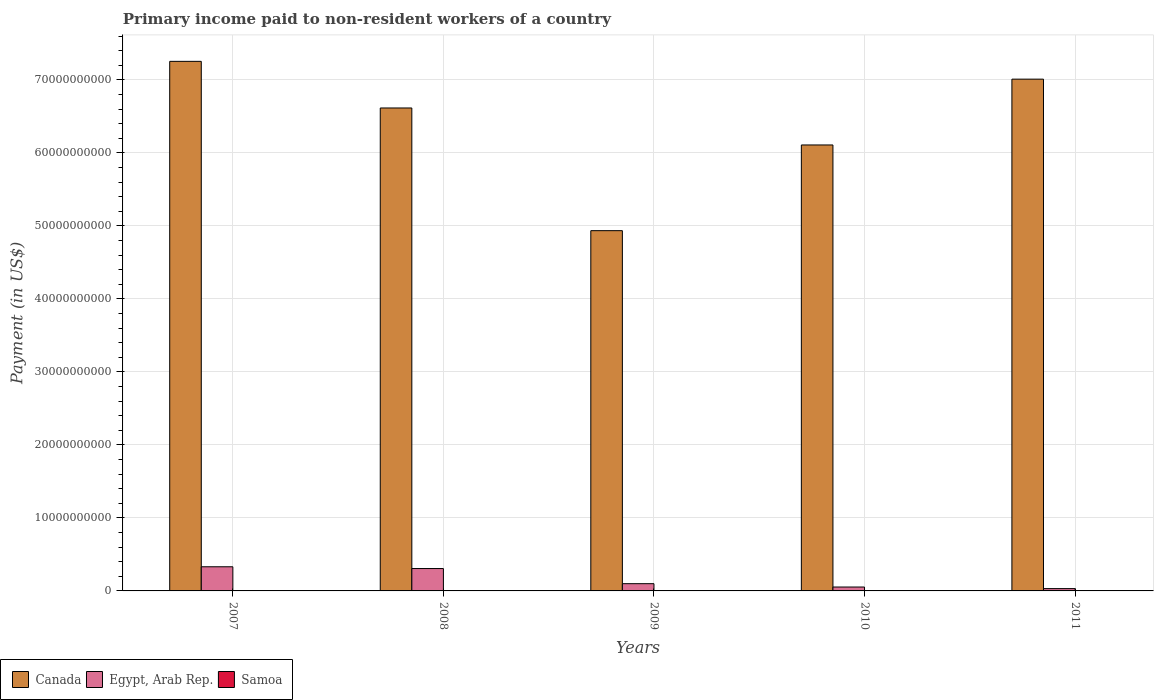How many different coloured bars are there?
Make the answer very short. 3. Are the number of bars per tick equal to the number of legend labels?
Ensure brevity in your answer.  Yes. What is the amount paid to workers in Egypt, Arab Rep. in 2011?
Offer a very short reply. 3.18e+08. Across all years, what is the maximum amount paid to workers in Canada?
Provide a succinct answer. 7.26e+1. Across all years, what is the minimum amount paid to workers in Egypt, Arab Rep.?
Keep it short and to the point. 3.18e+08. What is the total amount paid to workers in Egypt, Arab Rep. in the graph?
Your answer should be compact. 8.22e+09. What is the difference between the amount paid to workers in Egypt, Arab Rep. in 2007 and that in 2008?
Provide a short and direct response. 2.44e+08. What is the difference between the amount paid to workers in Samoa in 2008 and the amount paid to workers in Egypt, Arab Rep. in 2009?
Keep it short and to the point. -9.79e+08. What is the average amount paid to workers in Samoa per year?
Keep it short and to the point. 8.09e+06. In the year 2011, what is the difference between the amount paid to workers in Samoa and amount paid to workers in Canada?
Your response must be concise. -7.01e+1. What is the ratio of the amount paid to workers in Samoa in 2009 to that in 2011?
Make the answer very short. 1.34. Is the amount paid to workers in Egypt, Arab Rep. in 2008 less than that in 2010?
Give a very brief answer. No. Is the difference between the amount paid to workers in Samoa in 2009 and 2010 greater than the difference between the amount paid to workers in Canada in 2009 and 2010?
Your response must be concise. Yes. What is the difference between the highest and the second highest amount paid to workers in Samoa?
Make the answer very short. 5.60e+06. What is the difference between the highest and the lowest amount paid to workers in Egypt, Arab Rep.?
Your response must be concise. 2.99e+09. What does the 1st bar from the left in 2007 represents?
Provide a succinct answer. Canada. How many bars are there?
Provide a short and direct response. 15. Are all the bars in the graph horizontal?
Your response must be concise. No. Are the values on the major ticks of Y-axis written in scientific E-notation?
Your response must be concise. No. Does the graph contain any zero values?
Ensure brevity in your answer.  No. What is the title of the graph?
Your answer should be compact. Primary income paid to non-resident workers of a country. What is the label or title of the X-axis?
Offer a very short reply. Years. What is the label or title of the Y-axis?
Give a very brief answer. Payment (in US$). What is the Payment (in US$) in Canada in 2007?
Your response must be concise. 7.26e+1. What is the Payment (in US$) of Egypt, Arab Rep. in 2007?
Offer a very short reply. 3.31e+09. What is the Payment (in US$) in Samoa in 2007?
Give a very brief answer. 6.74e+06. What is the Payment (in US$) of Canada in 2008?
Offer a terse response. 6.62e+1. What is the Payment (in US$) of Egypt, Arab Rep. in 2008?
Your answer should be very brief. 3.07e+09. What is the Payment (in US$) of Samoa in 2008?
Give a very brief answer. 1.33e+07. What is the Payment (in US$) of Canada in 2009?
Provide a short and direct response. 4.94e+1. What is the Payment (in US$) of Egypt, Arab Rep. in 2009?
Give a very brief answer. 9.92e+08. What is the Payment (in US$) in Samoa in 2009?
Give a very brief answer. 7.75e+06. What is the Payment (in US$) of Canada in 2010?
Offer a terse response. 6.11e+1. What is the Payment (in US$) of Egypt, Arab Rep. in 2010?
Your response must be concise. 5.34e+08. What is the Payment (in US$) of Samoa in 2010?
Ensure brevity in your answer.  6.81e+06. What is the Payment (in US$) of Canada in 2011?
Your response must be concise. 7.01e+1. What is the Payment (in US$) in Egypt, Arab Rep. in 2011?
Ensure brevity in your answer.  3.18e+08. What is the Payment (in US$) of Samoa in 2011?
Offer a terse response. 5.80e+06. Across all years, what is the maximum Payment (in US$) of Canada?
Offer a very short reply. 7.26e+1. Across all years, what is the maximum Payment (in US$) in Egypt, Arab Rep.?
Offer a terse response. 3.31e+09. Across all years, what is the maximum Payment (in US$) of Samoa?
Keep it short and to the point. 1.33e+07. Across all years, what is the minimum Payment (in US$) of Canada?
Provide a short and direct response. 4.94e+1. Across all years, what is the minimum Payment (in US$) of Egypt, Arab Rep.?
Provide a succinct answer. 3.18e+08. Across all years, what is the minimum Payment (in US$) in Samoa?
Make the answer very short. 5.80e+06. What is the total Payment (in US$) in Canada in the graph?
Make the answer very short. 3.19e+11. What is the total Payment (in US$) of Egypt, Arab Rep. in the graph?
Offer a terse response. 8.22e+09. What is the total Payment (in US$) in Samoa in the graph?
Offer a very short reply. 4.04e+07. What is the difference between the Payment (in US$) in Canada in 2007 and that in 2008?
Offer a terse response. 6.39e+09. What is the difference between the Payment (in US$) of Egypt, Arab Rep. in 2007 and that in 2008?
Your answer should be very brief. 2.44e+08. What is the difference between the Payment (in US$) of Samoa in 2007 and that in 2008?
Your answer should be very brief. -6.61e+06. What is the difference between the Payment (in US$) of Canada in 2007 and that in 2009?
Provide a succinct answer. 2.32e+1. What is the difference between the Payment (in US$) in Egypt, Arab Rep. in 2007 and that in 2009?
Provide a succinct answer. 2.32e+09. What is the difference between the Payment (in US$) in Samoa in 2007 and that in 2009?
Give a very brief answer. -1.01e+06. What is the difference between the Payment (in US$) of Canada in 2007 and that in 2010?
Your response must be concise. 1.15e+1. What is the difference between the Payment (in US$) in Egypt, Arab Rep. in 2007 and that in 2010?
Make the answer very short. 2.78e+09. What is the difference between the Payment (in US$) in Samoa in 2007 and that in 2010?
Provide a short and direct response. -7.51e+04. What is the difference between the Payment (in US$) in Canada in 2007 and that in 2011?
Give a very brief answer. 2.44e+09. What is the difference between the Payment (in US$) in Egypt, Arab Rep. in 2007 and that in 2011?
Offer a very short reply. 2.99e+09. What is the difference between the Payment (in US$) in Samoa in 2007 and that in 2011?
Your answer should be compact. 9.42e+05. What is the difference between the Payment (in US$) in Canada in 2008 and that in 2009?
Provide a succinct answer. 1.68e+1. What is the difference between the Payment (in US$) in Egypt, Arab Rep. in 2008 and that in 2009?
Your response must be concise. 2.07e+09. What is the difference between the Payment (in US$) of Samoa in 2008 and that in 2009?
Provide a succinct answer. 5.60e+06. What is the difference between the Payment (in US$) in Canada in 2008 and that in 2010?
Offer a very short reply. 5.07e+09. What is the difference between the Payment (in US$) in Egypt, Arab Rep. in 2008 and that in 2010?
Ensure brevity in your answer.  2.53e+09. What is the difference between the Payment (in US$) in Samoa in 2008 and that in 2010?
Make the answer very short. 6.53e+06. What is the difference between the Payment (in US$) in Canada in 2008 and that in 2011?
Give a very brief answer. -3.95e+09. What is the difference between the Payment (in US$) of Egypt, Arab Rep. in 2008 and that in 2011?
Provide a succinct answer. 2.75e+09. What is the difference between the Payment (in US$) in Samoa in 2008 and that in 2011?
Offer a terse response. 7.55e+06. What is the difference between the Payment (in US$) of Canada in 2009 and that in 2010?
Provide a short and direct response. -1.17e+1. What is the difference between the Payment (in US$) of Egypt, Arab Rep. in 2009 and that in 2010?
Your answer should be compact. 4.58e+08. What is the difference between the Payment (in US$) in Samoa in 2009 and that in 2010?
Provide a succinct answer. 9.38e+05. What is the difference between the Payment (in US$) of Canada in 2009 and that in 2011?
Your response must be concise. -2.08e+1. What is the difference between the Payment (in US$) of Egypt, Arab Rep. in 2009 and that in 2011?
Make the answer very short. 6.74e+08. What is the difference between the Payment (in US$) of Samoa in 2009 and that in 2011?
Your answer should be compact. 1.95e+06. What is the difference between the Payment (in US$) in Canada in 2010 and that in 2011?
Provide a short and direct response. -9.02e+09. What is the difference between the Payment (in US$) of Egypt, Arab Rep. in 2010 and that in 2011?
Give a very brief answer. 2.16e+08. What is the difference between the Payment (in US$) of Samoa in 2010 and that in 2011?
Provide a succinct answer. 1.02e+06. What is the difference between the Payment (in US$) in Canada in 2007 and the Payment (in US$) in Egypt, Arab Rep. in 2008?
Ensure brevity in your answer.  6.95e+1. What is the difference between the Payment (in US$) of Canada in 2007 and the Payment (in US$) of Samoa in 2008?
Provide a succinct answer. 7.25e+1. What is the difference between the Payment (in US$) in Egypt, Arab Rep. in 2007 and the Payment (in US$) in Samoa in 2008?
Ensure brevity in your answer.  3.30e+09. What is the difference between the Payment (in US$) in Canada in 2007 and the Payment (in US$) in Egypt, Arab Rep. in 2009?
Give a very brief answer. 7.16e+1. What is the difference between the Payment (in US$) in Canada in 2007 and the Payment (in US$) in Samoa in 2009?
Your answer should be very brief. 7.25e+1. What is the difference between the Payment (in US$) of Egypt, Arab Rep. in 2007 and the Payment (in US$) of Samoa in 2009?
Offer a terse response. 3.30e+09. What is the difference between the Payment (in US$) in Canada in 2007 and the Payment (in US$) in Egypt, Arab Rep. in 2010?
Your response must be concise. 7.20e+1. What is the difference between the Payment (in US$) of Canada in 2007 and the Payment (in US$) of Samoa in 2010?
Provide a succinct answer. 7.25e+1. What is the difference between the Payment (in US$) of Egypt, Arab Rep. in 2007 and the Payment (in US$) of Samoa in 2010?
Your answer should be compact. 3.30e+09. What is the difference between the Payment (in US$) in Canada in 2007 and the Payment (in US$) in Egypt, Arab Rep. in 2011?
Keep it short and to the point. 7.22e+1. What is the difference between the Payment (in US$) in Canada in 2007 and the Payment (in US$) in Samoa in 2011?
Provide a succinct answer. 7.25e+1. What is the difference between the Payment (in US$) of Egypt, Arab Rep. in 2007 and the Payment (in US$) of Samoa in 2011?
Provide a succinct answer. 3.30e+09. What is the difference between the Payment (in US$) of Canada in 2008 and the Payment (in US$) of Egypt, Arab Rep. in 2009?
Your answer should be very brief. 6.52e+1. What is the difference between the Payment (in US$) of Canada in 2008 and the Payment (in US$) of Samoa in 2009?
Give a very brief answer. 6.62e+1. What is the difference between the Payment (in US$) of Egypt, Arab Rep. in 2008 and the Payment (in US$) of Samoa in 2009?
Your response must be concise. 3.06e+09. What is the difference between the Payment (in US$) in Canada in 2008 and the Payment (in US$) in Egypt, Arab Rep. in 2010?
Your response must be concise. 6.56e+1. What is the difference between the Payment (in US$) in Canada in 2008 and the Payment (in US$) in Samoa in 2010?
Provide a short and direct response. 6.62e+1. What is the difference between the Payment (in US$) in Egypt, Arab Rep. in 2008 and the Payment (in US$) in Samoa in 2010?
Your answer should be compact. 3.06e+09. What is the difference between the Payment (in US$) of Canada in 2008 and the Payment (in US$) of Egypt, Arab Rep. in 2011?
Your answer should be compact. 6.58e+1. What is the difference between the Payment (in US$) of Canada in 2008 and the Payment (in US$) of Samoa in 2011?
Ensure brevity in your answer.  6.62e+1. What is the difference between the Payment (in US$) of Egypt, Arab Rep. in 2008 and the Payment (in US$) of Samoa in 2011?
Your response must be concise. 3.06e+09. What is the difference between the Payment (in US$) in Canada in 2009 and the Payment (in US$) in Egypt, Arab Rep. in 2010?
Offer a very short reply. 4.88e+1. What is the difference between the Payment (in US$) in Canada in 2009 and the Payment (in US$) in Samoa in 2010?
Your response must be concise. 4.94e+1. What is the difference between the Payment (in US$) of Egypt, Arab Rep. in 2009 and the Payment (in US$) of Samoa in 2010?
Keep it short and to the point. 9.85e+08. What is the difference between the Payment (in US$) in Canada in 2009 and the Payment (in US$) in Egypt, Arab Rep. in 2011?
Give a very brief answer. 4.90e+1. What is the difference between the Payment (in US$) in Canada in 2009 and the Payment (in US$) in Samoa in 2011?
Your answer should be very brief. 4.94e+1. What is the difference between the Payment (in US$) in Egypt, Arab Rep. in 2009 and the Payment (in US$) in Samoa in 2011?
Your answer should be compact. 9.86e+08. What is the difference between the Payment (in US$) in Canada in 2010 and the Payment (in US$) in Egypt, Arab Rep. in 2011?
Ensure brevity in your answer.  6.08e+1. What is the difference between the Payment (in US$) of Canada in 2010 and the Payment (in US$) of Samoa in 2011?
Offer a very short reply. 6.11e+1. What is the difference between the Payment (in US$) of Egypt, Arab Rep. in 2010 and the Payment (in US$) of Samoa in 2011?
Provide a succinct answer. 5.28e+08. What is the average Payment (in US$) of Canada per year?
Offer a terse response. 6.39e+1. What is the average Payment (in US$) in Egypt, Arab Rep. per year?
Offer a very short reply. 1.64e+09. What is the average Payment (in US$) in Samoa per year?
Offer a terse response. 8.09e+06. In the year 2007, what is the difference between the Payment (in US$) in Canada and Payment (in US$) in Egypt, Arab Rep.?
Provide a succinct answer. 6.92e+1. In the year 2007, what is the difference between the Payment (in US$) in Canada and Payment (in US$) in Samoa?
Offer a very short reply. 7.25e+1. In the year 2007, what is the difference between the Payment (in US$) in Egypt, Arab Rep. and Payment (in US$) in Samoa?
Keep it short and to the point. 3.30e+09. In the year 2008, what is the difference between the Payment (in US$) in Canada and Payment (in US$) in Egypt, Arab Rep.?
Keep it short and to the point. 6.31e+1. In the year 2008, what is the difference between the Payment (in US$) of Canada and Payment (in US$) of Samoa?
Your answer should be compact. 6.62e+1. In the year 2008, what is the difference between the Payment (in US$) of Egypt, Arab Rep. and Payment (in US$) of Samoa?
Your answer should be compact. 3.05e+09. In the year 2009, what is the difference between the Payment (in US$) in Canada and Payment (in US$) in Egypt, Arab Rep.?
Provide a short and direct response. 4.84e+1. In the year 2009, what is the difference between the Payment (in US$) in Canada and Payment (in US$) in Samoa?
Provide a succinct answer. 4.93e+1. In the year 2009, what is the difference between the Payment (in US$) of Egypt, Arab Rep. and Payment (in US$) of Samoa?
Provide a succinct answer. 9.84e+08. In the year 2010, what is the difference between the Payment (in US$) in Canada and Payment (in US$) in Egypt, Arab Rep.?
Your response must be concise. 6.06e+1. In the year 2010, what is the difference between the Payment (in US$) in Canada and Payment (in US$) in Samoa?
Make the answer very short. 6.11e+1. In the year 2010, what is the difference between the Payment (in US$) of Egypt, Arab Rep. and Payment (in US$) of Samoa?
Provide a succinct answer. 5.27e+08. In the year 2011, what is the difference between the Payment (in US$) in Canada and Payment (in US$) in Egypt, Arab Rep.?
Your answer should be compact. 6.98e+1. In the year 2011, what is the difference between the Payment (in US$) in Canada and Payment (in US$) in Samoa?
Your response must be concise. 7.01e+1. In the year 2011, what is the difference between the Payment (in US$) in Egypt, Arab Rep. and Payment (in US$) in Samoa?
Give a very brief answer. 3.12e+08. What is the ratio of the Payment (in US$) of Canada in 2007 to that in 2008?
Your answer should be very brief. 1.1. What is the ratio of the Payment (in US$) in Egypt, Arab Rep. in 2007 to that in 2008?
Keep it short and to the point. 1.08. What is the ratio of the Payment (in US$) in Samoa in 2007 to that in 2008?
Ensure brevity in your answer.  0.5. What is the ratio of the Payment (in US$) of Canada in 2007 to that in 2009?
Offer a very short reply. 1.47. What is the ratio of the Payment (in US$) in Egypt, Arab Rep. in 2007 to that in 2009?
Your answer should be compact. 3.34. What is the ratio of the Payment (in US$) of Samoa in 2007 to that in 2009?
Provide a short and direct response. 0.87. What is the ratio of the Payment (in US$) in Canada in 2007 to that in 2010?
Keep it short and to the point. 1.19. What is the ratio of the Payment (in US$) in Egypt, Arab Rep. in 2007 to that in 2010?
Provide a succinct answer. 6.2. What is the ratio of the Payment (in US$) of Samoa in 2007 to that in 2010?
Provide a succinct answer. 0.99. What is the ratio of the Payment (in US$) in Canada in 2007 to that in 2011?
Make the answer very short. 1.03. What is the ratio of the Payment (in US$) in Egypt, Arab Rep. in 2007 to that in 2011?
Ensure brevity in your answer.  10.41. What is the ratio of the Payment (in US$) of Samoa in 2007 to that in 2011?
Ensure brevity in your answer.  1.16. What is the ratio of the Payment (in US$) of Canada in 2008 to that in 2009?
Make the answer very short. 1.34. What is the ratio of the Payment (in US$) in Egypt, Arab Rep. in 2008 to that in 2009?
Offer a terse response. 3.09. What is the ratio of the Payment (in US$) of Samoa in 2008 to that in 2009?
Your answer should be very brief. 1.72. What is the ratio of the Payment (in US$) in Canada in 2008 to that in 2010?
Make the answer very short. 1.08. What is the ratio of the Payment (in US$) of Egypt, Arab Rep. in 2008 to that in 2010?
Provide a succinct answer. 5.74. What is the ratio of the Payment (in US$) in Samoa in 2008 to that in 2010?
Your answer should be very brief. 1.96. What is the ratio of the Payment (in US$) in Canada in 2008 to that in 2011?
Your answer should be very brief. 0.94. What is the ratio of the Payment (in US$) of Egypt, Arab Rep. in 2008 to that in 2011?
Keep it short and to the point. 9.65. What is the ratio of the Payment (in US$) of Samoa in 2008 to that in 2011?
Make the answer very short. 2.3. What is the ratio of the Payment (in US$) of Canada in 2009 to that in 2010?
Offer a very short reply. 0.81. What is the ratio of the Payment (in US$) of Egypt, Arab Rep. in 2009 to that in 2010?
Offer a terse response. 1.86. What is the ratio of the Payment (in US$) of Samoa in 2009 to that in 2010?
Your answer should be very brief. 1.14. What is the ratio of the Payment (in US$) in Canada in 2009 to that in 2011?
Offer a terse response. 0.7. What is the ratio of the Payment (in US$) in Egypt, Arab Rep. in 2009 to that in 2011?
Keep it short and to the point. 3.12. What is the ratio of the Payment (in US$) of Samoa in 2009 to that in 2011?
Provide a succinct answer. 1.34. What is the ratio of the Payment (in US$) in Canada in 2010 to that in 2011?
Your answer should be compact. 0.87. What is the ratio of the Payment (in US$) of Egypt, Arab Rep. in 2010 to that in 2011?
Make the answer very short. 1.68. What is the ratio of the Payment (in US$) of Samoa in 2010 to that in 2011?
Make the answer very short. 1.18. What is the difference between the highest and the second highest Payment (in US$) of Canada?
Make the answer very short. 2.44e+09. What is the difference between the highest and the second highest Payment (in US$) of Egypt, Arab Rep.?
Offer a terse response. 2.44e+08. What is the difference between the highest and the second highest Payment (in US$) in Samoa?
Provide a short and direct response. 5.60e+06. What is the difference between the highest and the lowest Payment (in US$) in Canada?
Offer a very short reply. 2.32e+1. What is the difference between the highest and the lowest Payment (in US$) of Egypt, Arab Rep.?
Offer a very short reply. 2.99e+09. What is the difference between the highest and the lowest Payment (in US$) in Samoa?
Your answer should be very brief. 7.55e+06. 